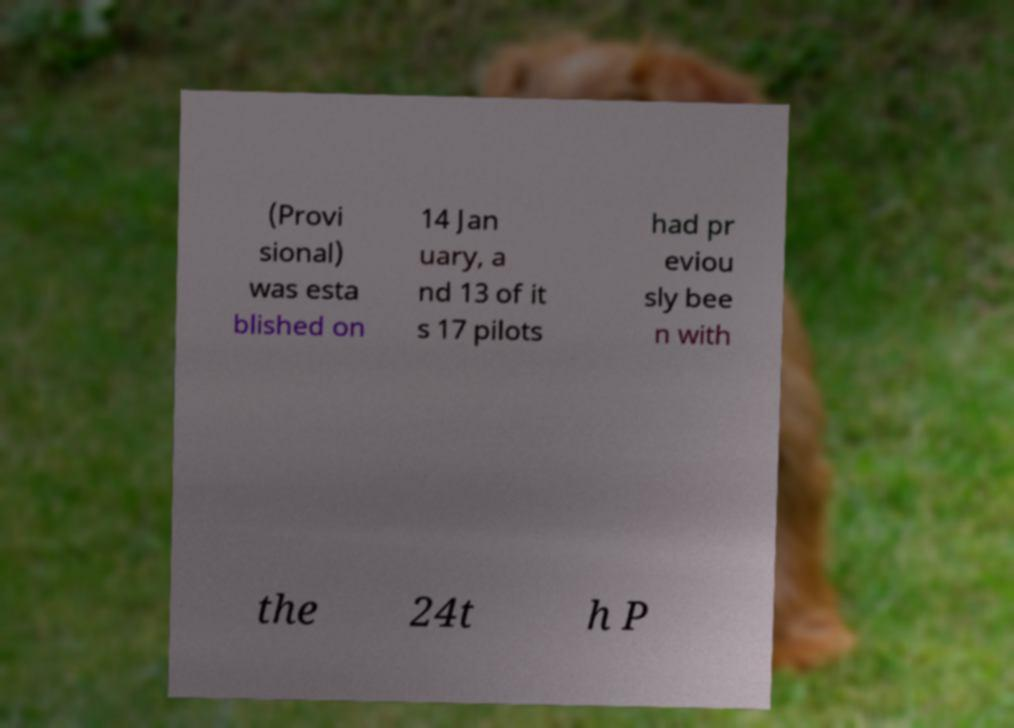For documentation purposes, I need the text within this image transcribed. Could you provide that? (Provi sional) was esta blished on 14 Jan uary, a nd 13 of it s 17 pilots had pr eviou sly bee n with the 24t h P 